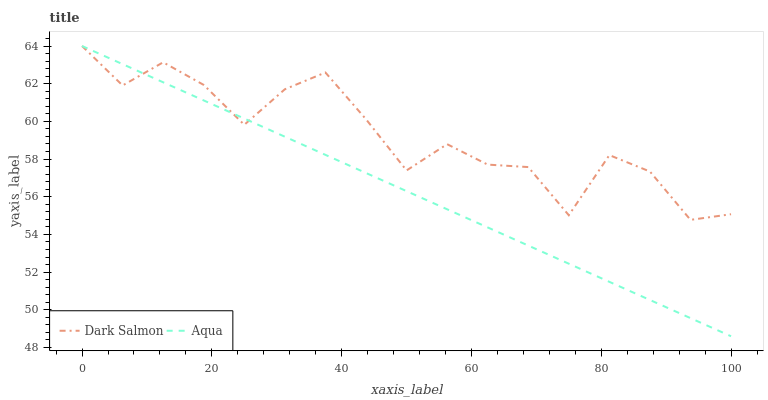Does Aqua have the minimum area under the curve?
Answer yes or no. Yes. Does Dark Salmon have the maximum area under the curve?
Answer yes or no. Yes. Does Dark Salmon have the minimum area under the curve?
Answer yes or no. No. Is Aqua the smoothest?
Answer yes or no. Yes. Is Dark Salmon the roughest?
Answer yes or no. Yes. Is Dark Salmon the smoothest?
Answer yes or no. No. Does Aqua have the lowest value?
Answer yes or no. Yes. Does Dark Salmon have the lowest value?
Answer yes or no. No. Does Dark Salmon have the highest value?
Answer yes or no. Yes. Does Aqua intersect Dark Salmon?
Answer yes or no. Yes. Is Aqua less than Dark Salmon?
Answer yes or no. No. Is Aqua greater than Dark Salmon?
Answer yes or no. No. 